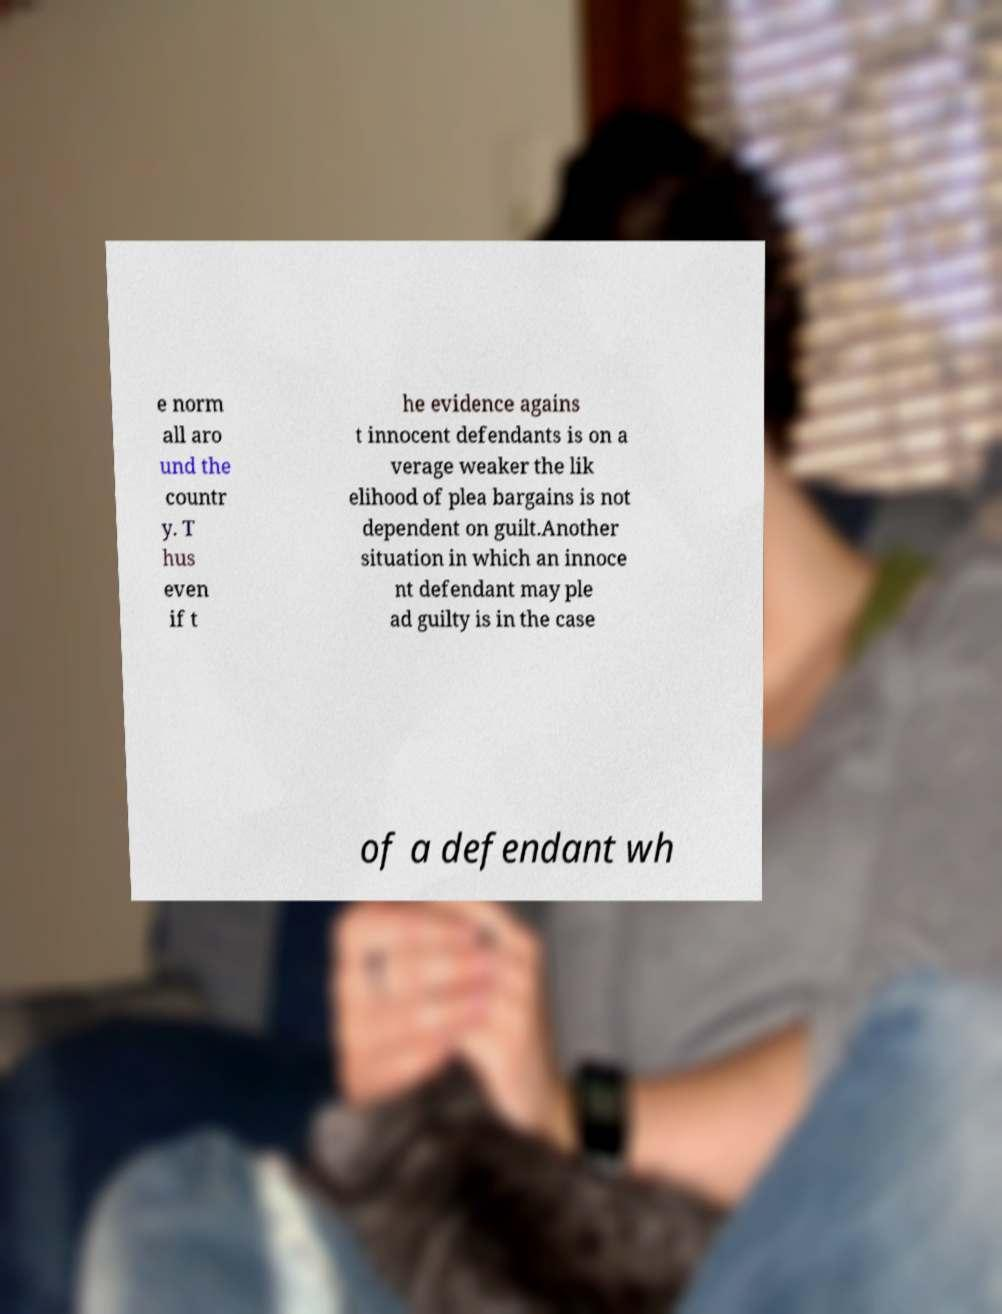Could you assist in decoding the text presented in this image and type it out clearly? e norm all aro und the countr y. T hus even if t he evidence agains t innocent defendants is on a verage weaker the lik elihood of plea bargains is not dependent on guilt.Another situation in which an innoce nt defendant may ple ad guilty is in the case of a defendant wh 